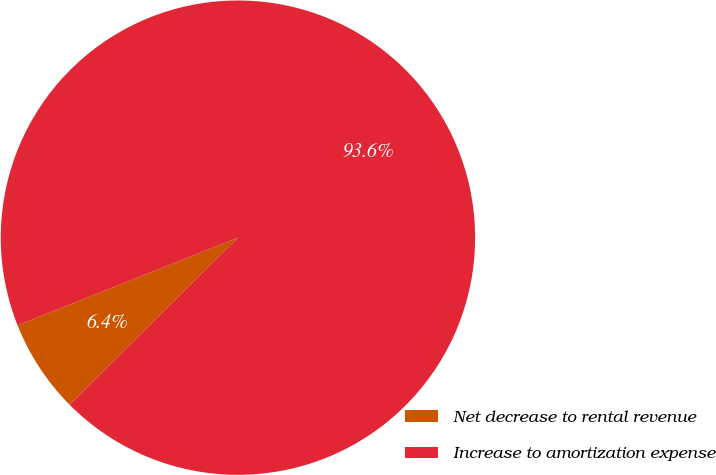Convert chart. <chart><loc_0><loc_0><loc_500><loc_500><pie_chart><fcel>Net decrease to rental revenue<fcel>Increase to amortization expense<nl><fcel>6.41%<fcel>93.59%<nl></chart> 